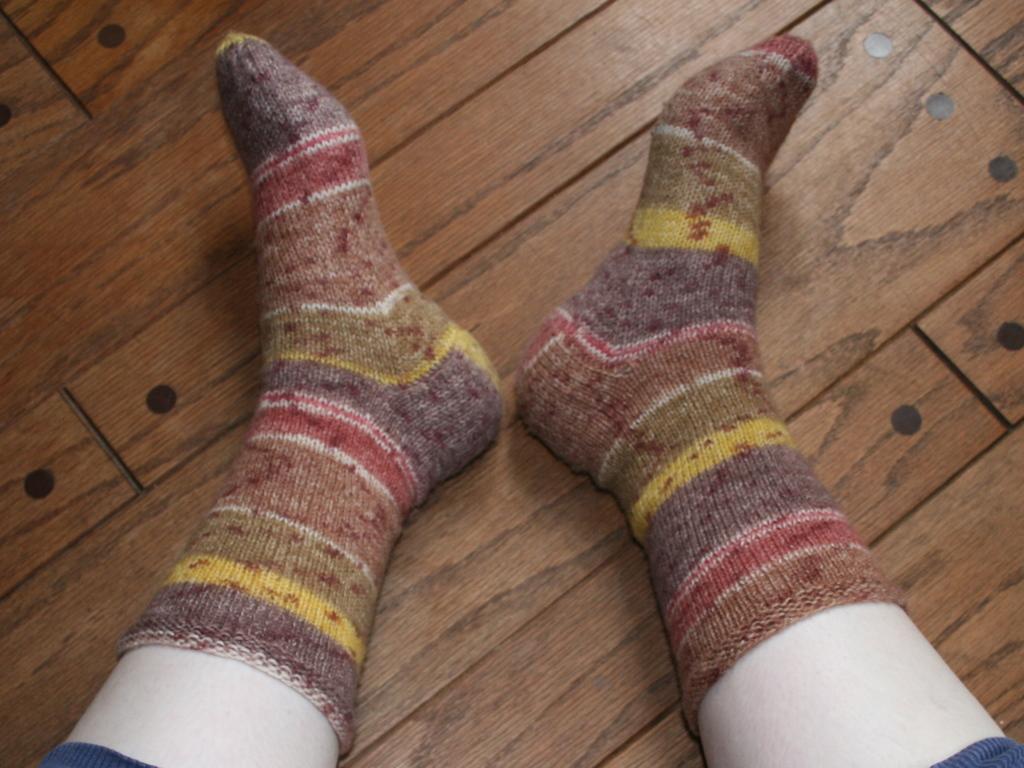Describe this image in one or two sentences. In this image we can see a person's legs on the floor. 